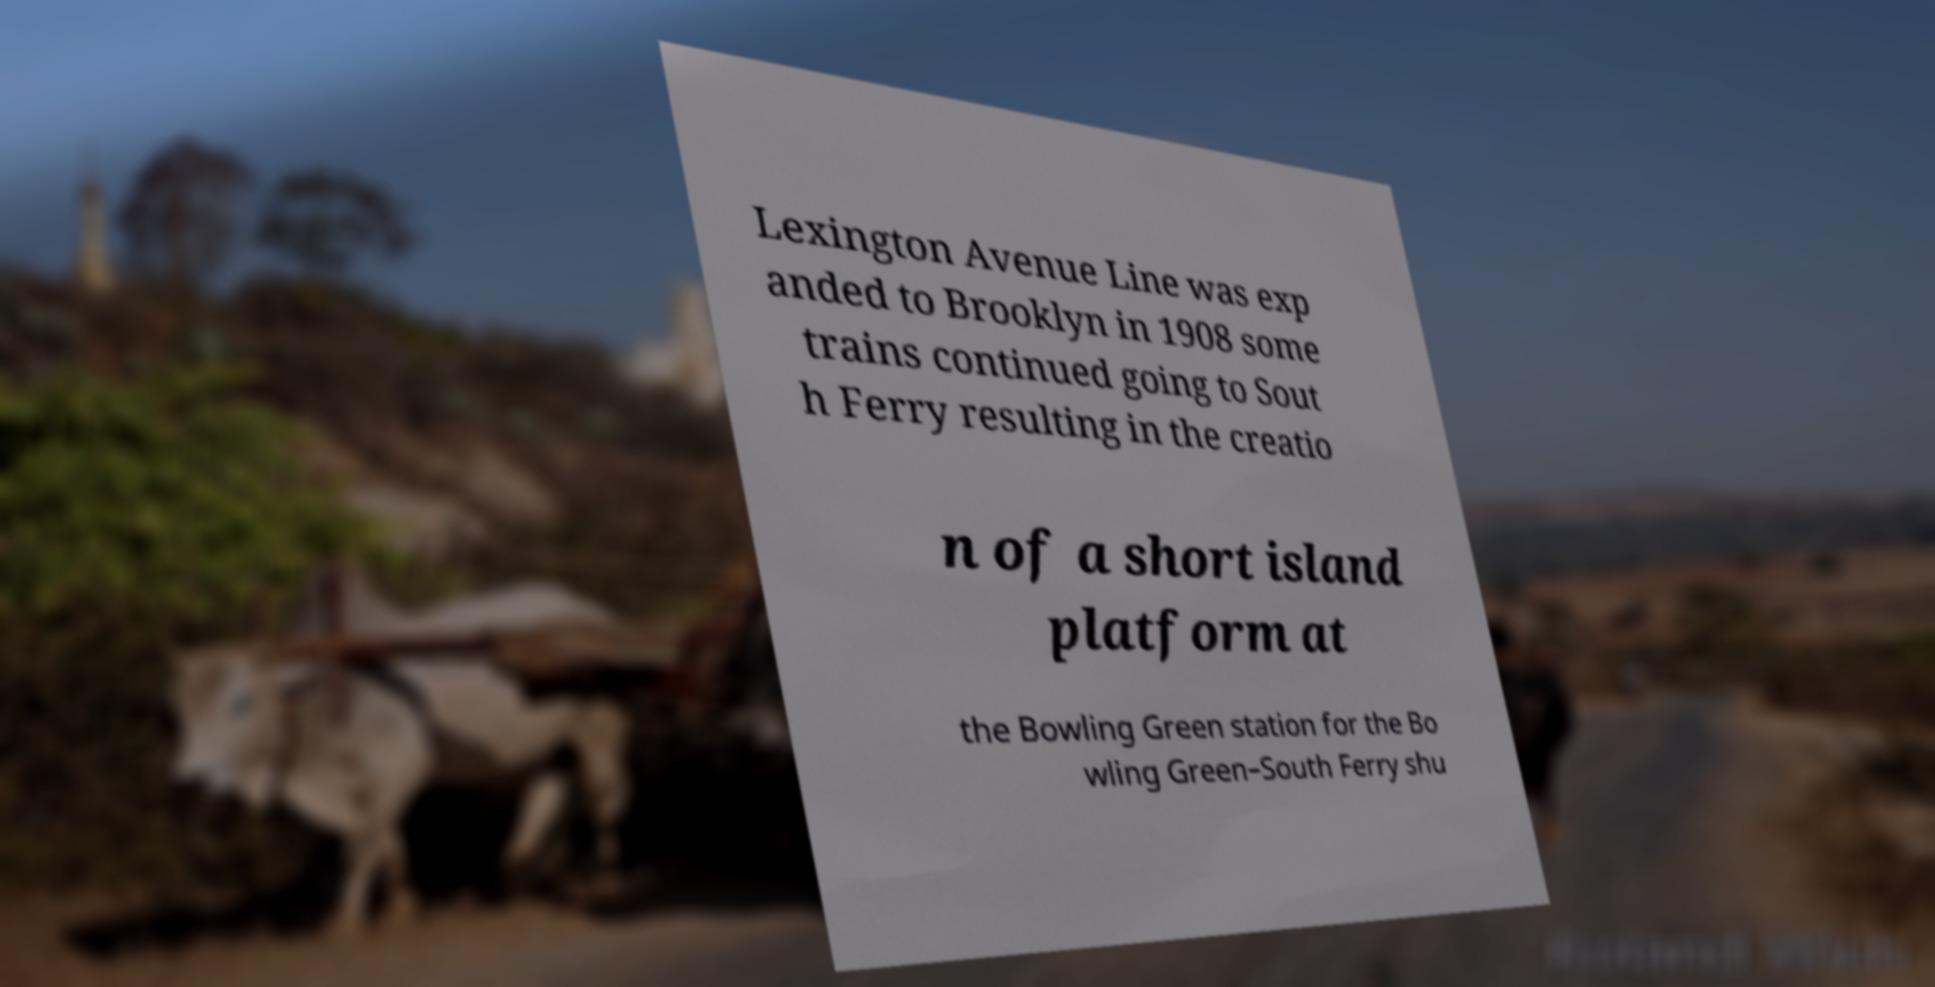Please identify and transcribe the text found in this image. Lexington Avenue Line was exp anded to Brooklyn in 1908 some trains continued going to Sout h Ferry resulting in the creatio n of a short island platform at the Bowling Green station for the Bo wling Green–South Ferry shu 